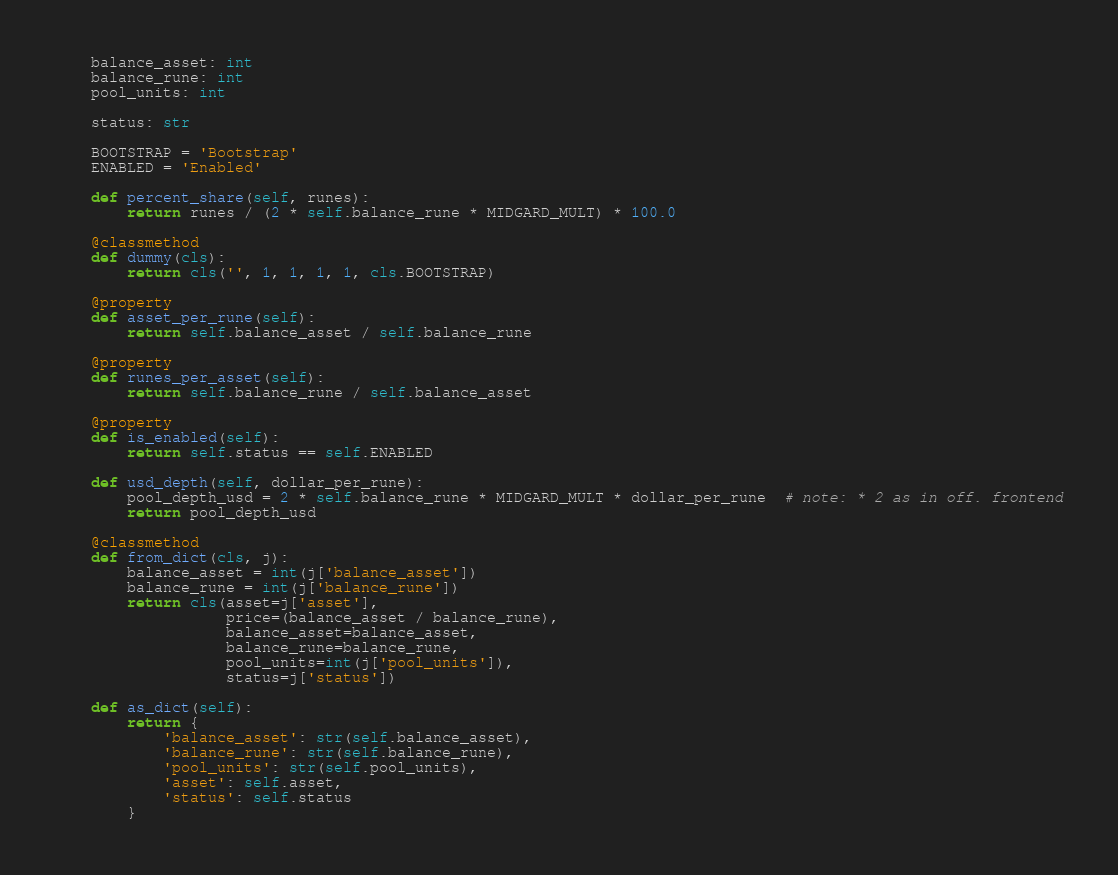Convert code to text. <code><loc_0><loc_0><loc_500><loc_500><_Python_>
    balance_asset: int
    balance_rune: int
    pool_units: int

    status: str

    BOOTSTRAP = 'Bootstrap'
    ENABLED = 'Enabled'

    def percent_share(self, runes):
        return runes / (2 * self.balance_rune * MIDGARD_MULT) * 100.0

    @classmethod
    def dummy(cls):
        return cls('', 1, 1, 1, 1, cls.BOOTSTRAP)

    @property
    def asset_per_rune(self):
        return self.balance_asset / self.balance_rune

    @property
    def runes_per_asset(self):
        return self.balance_rune / self.balance_asset

    @property
    def is_enabled(self):
        return self.status == self.ENABLED

    def usd_depth(self, dollar_per_rune):
        pool_depth_usd = 2 * self.balance_rune * MIDGARD_MULT * dollar_per_rune  # note: * 2 as in off. frontend
        return pool_depth_usd

    @classmethod
    def from_dict(cls, j):
        balance_asset = int(j['balance_asset'])
        balance_rune = int(j['balance_rune'])
        return cls(asset=j['asset'],
                   price=(balance_asset / balance_rune),
                   balance_asset=balance_asset,
                   balance_rune=balance_rune,
                   pool_units=int(j['pool_units']),
                   status=j['status'])

    def as_dict(self):
        return {
            'balance_asset': str(self.balance_asset),
            'balance_rune': str(self.balance_rune),
            'pool_units': str(self.pool_units),
            'asset': self.asset,
            'status': self.status
        }
</code> 